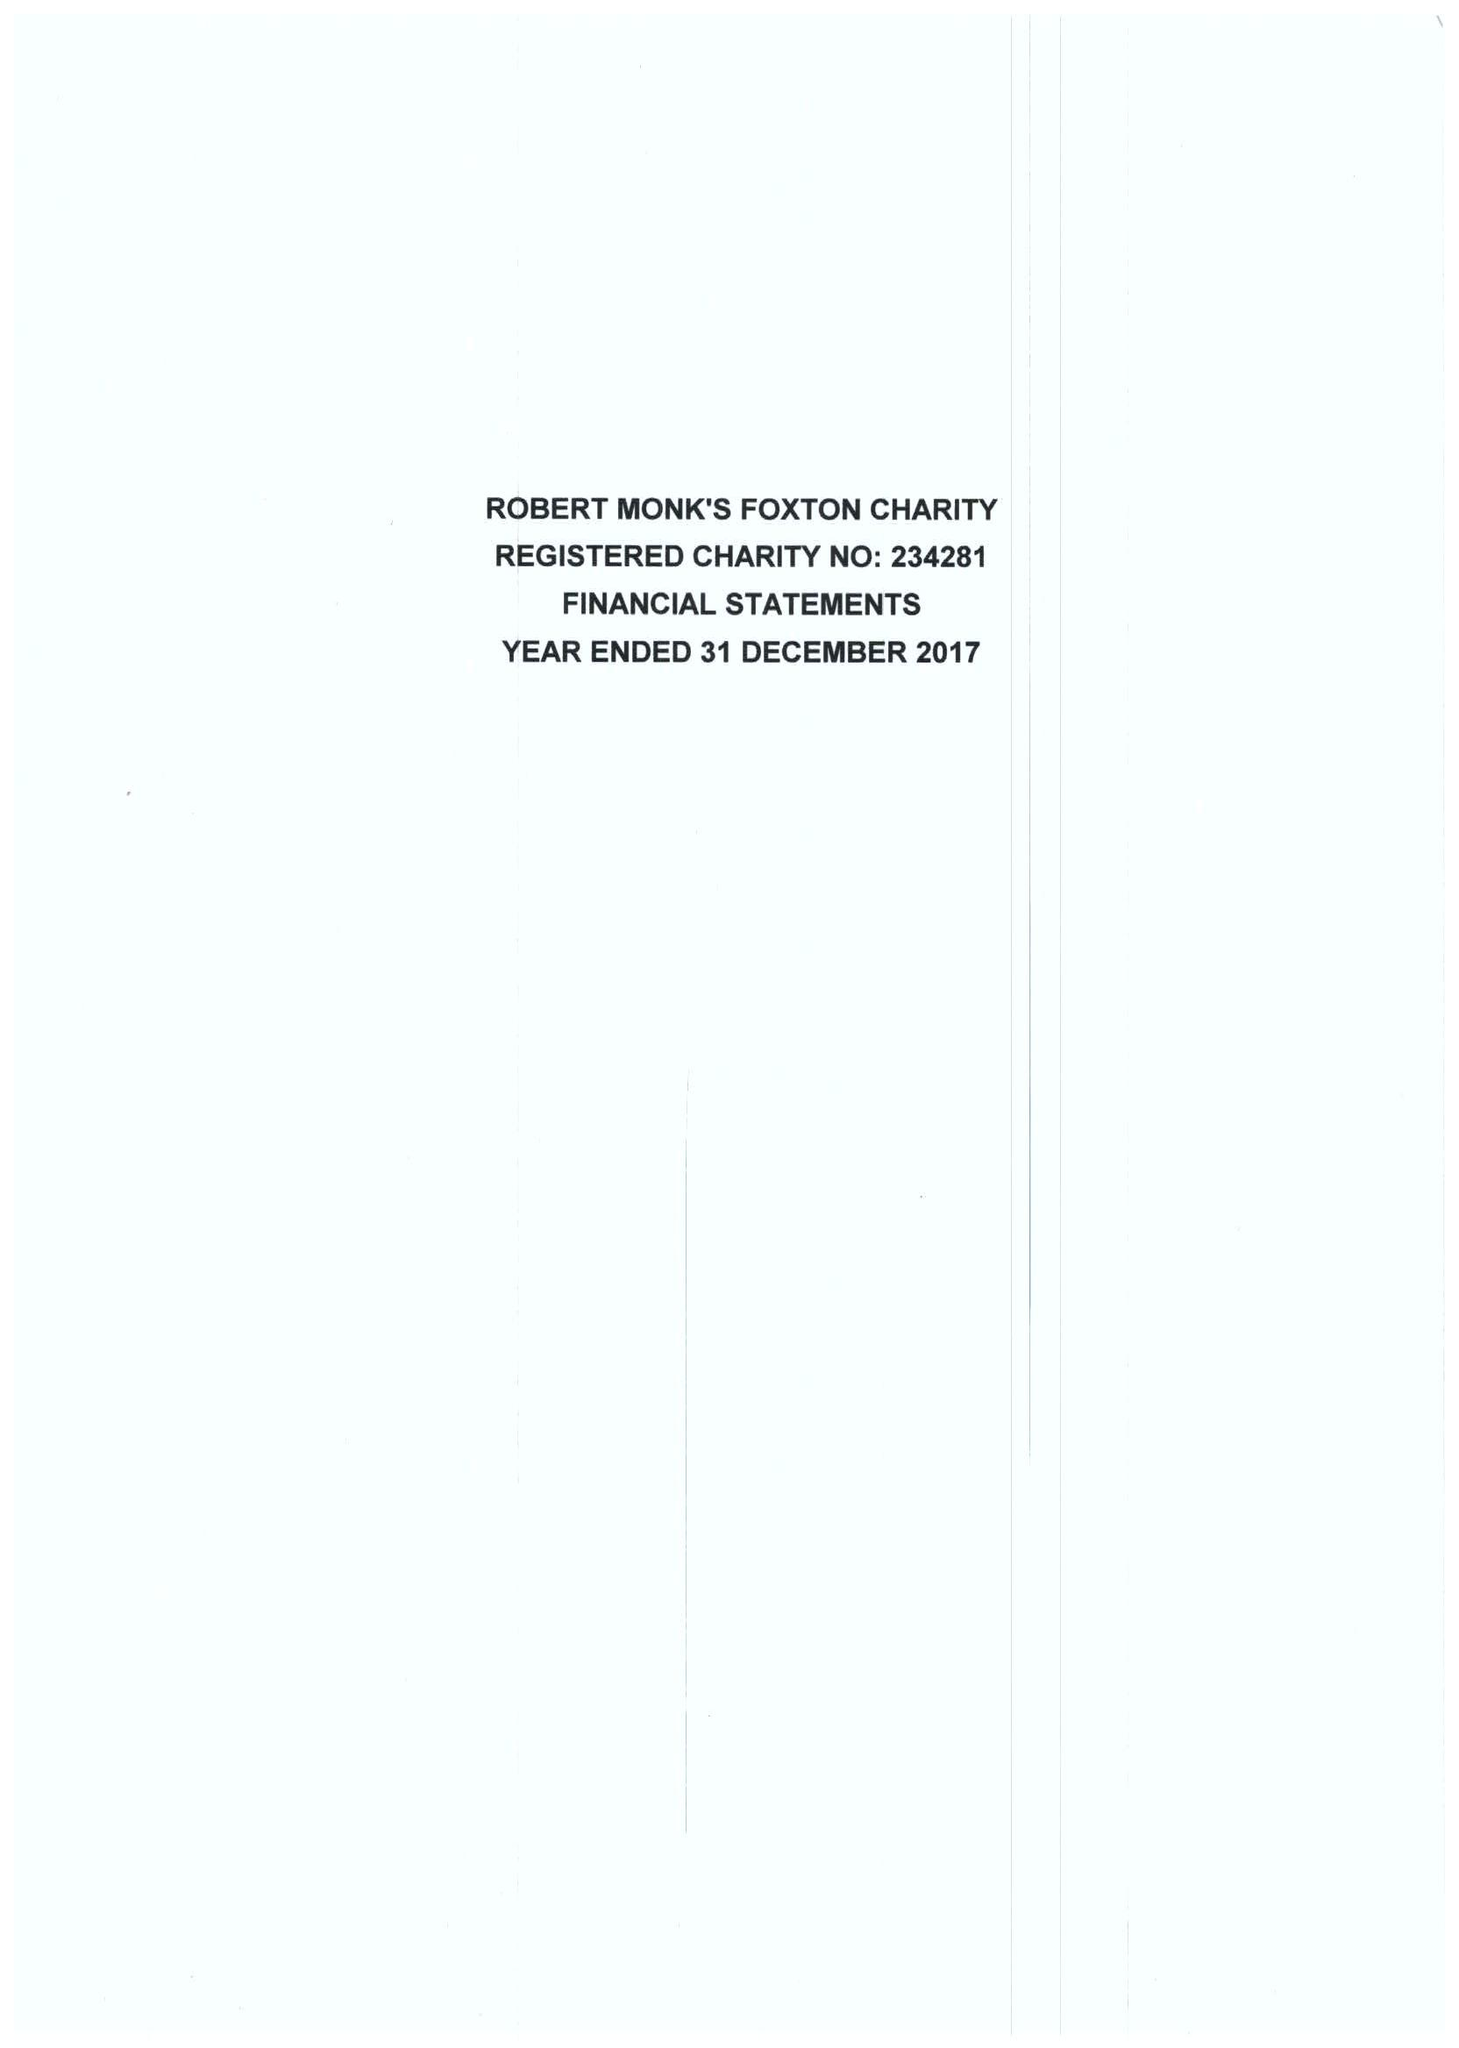What is the value for the spending_annually_in_british_pounds?
Answer the question using a single word or phrase. 32180.00 